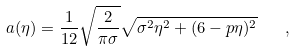Convert formula to latex. <formula><loc_0><loc_0><loc_500><loc_500>a ( \eta ) = \frac { 1 } { 1 2 } \sqrt { \frac { 2 } { \pi \sigma } } \sqrt { \sigma ^ { 2 } \eta ^ { 2 } + ( 6 - p \eta ) ^ { 2 } } \quad ,</formula> 